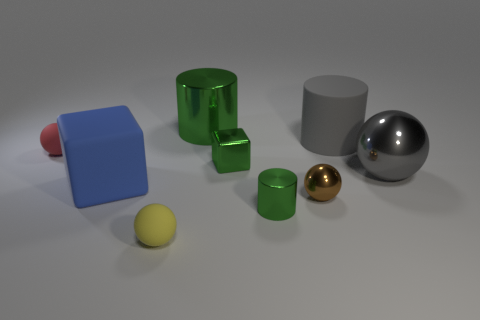How big is the metallic ball that is right of the brown shiny ball that is left of the large gray object in front of the red rubber ball?
Offer a very short reply. Large. Are there more green cylinders behind the large gray ball than large brown cylinders?
Offer a terse response. Yes. Is there a brown shiny sphere?
Your response must be concise. Yes. How many gray shiny objects have the same size as the yellow object?
Ensure brevity in your answer.  0. Are there more shiny cylinders that are behind the red rubber ball than tiny shiny spheres that are to the left of the yellow object?
Offer a terse response. Yes. What is the material of the green cube that is the same size as the brown metal sphere?
Offer a terse response. Metal. What is the shape of the small yellow object?
Your response must be concise. Sphere. How many cyan objects are shiny cubes or tiny cylinders?
Your answer should be very brief. 0. What size is the brown object that is the same material as the small cube?
Your answer should be very brief. Small. Is the material of the red sphere that is left of the small metallic cube the same as the ball in front of the small brown object?
Provide a short and direct response. Yes. 